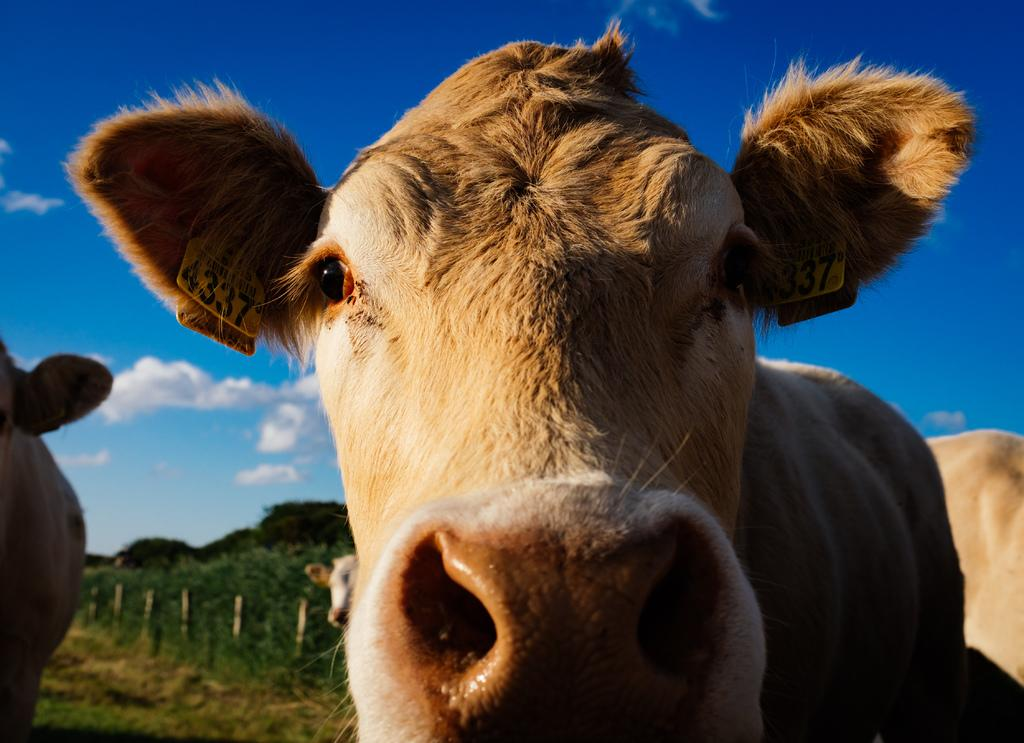What animals are present in the image? There are cows in the image. What can be seen in the background of the image? There are trees and the sky visible in the background of the image. What type of silk can be seen draped over the cows in the image? There is no silk present in the image; it features cows with no additional clothing or accessories. 